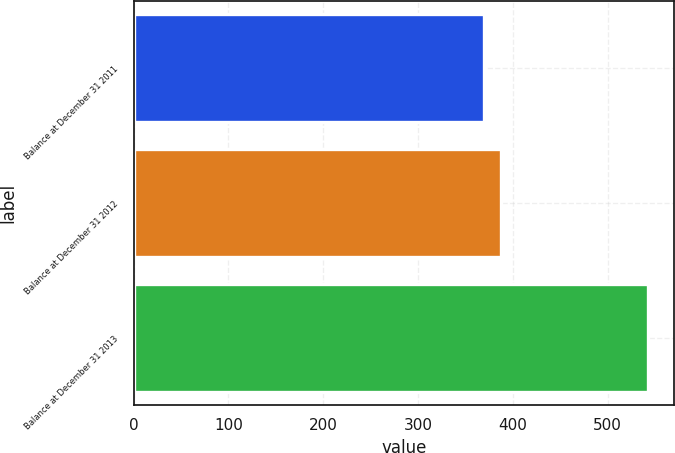Convert chart to OTSL. <chart><loc_0><loc_0><loc_500><loc_500><bar_chart><fcel>Balance at December 31 2011<fcel>Balance at December 31 2012<fcel>Balance at December 31 2013<nl><fcel>370<fcel>387.3<fcel>543<nl></chart> 